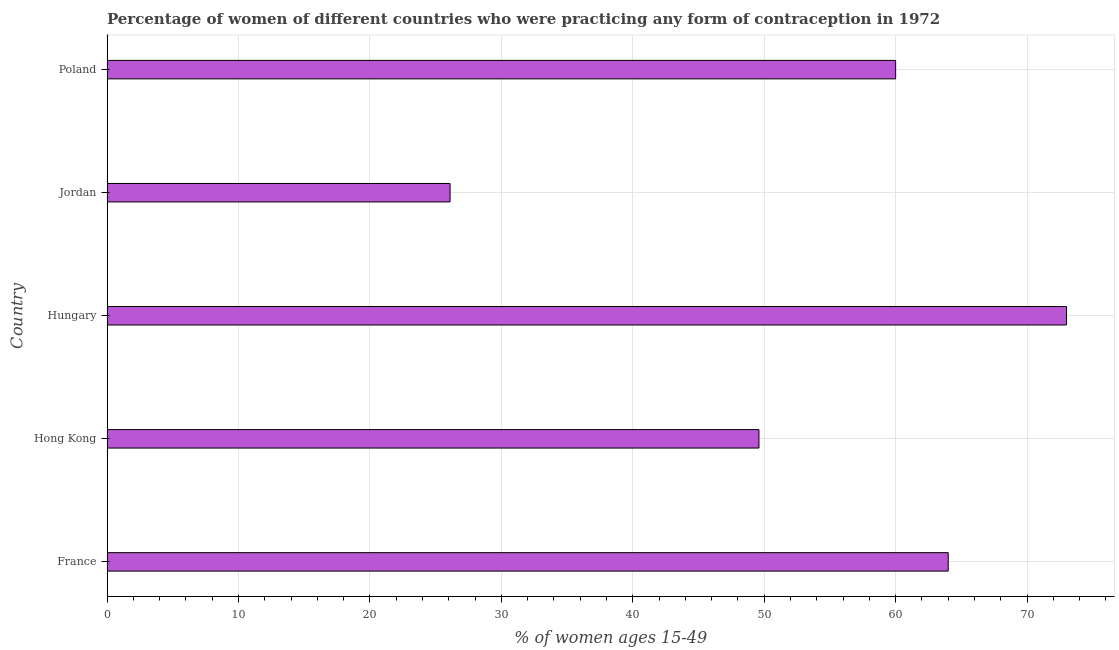Does the graph contain any zero values?
Provide a succinct answer. No. Does the graph contain grids?
Provide a succinct answer. Yes. What is the title of the graph?
Provide a succinct answer. Percentage of women of different countries who were practicing any form of contraception in 1972. What is the label or title of the X-axis?
Offer a terse response. % of women ages 15-49. Across all countries, what is the maximum contraceptive prevalence?
Keep it short and to the point. 73. Across all countries, what is the minimum contraceptive prevalence?
Your answer should be compact. 26.1. In which country was the contraceptive prevalence maximum?
Ensure brevity in your answer.  Hungary. In which country was the contraceptive prevalence minimum?
Ensure brevity in your answer.  Jordan. What is the sum of the contraceptive prevalence?
Provide a short and direct response. 272.7. What is the average contraceptive prevalence per country?
Your answer should be compact. 54.54. In how many countries, is the contraceptive prevalence greater than 8 %?
Give a very brief answer. 5. What is the ratio of the contraceptive prevalence in Hungary to that in Jordan?
Your response must be concise. 2.8. Is the contraceptive prevalence in Hong Kong less than that in Jordan?
Your response must be concise. No. Is the difference between the contraceptive prevalence in Hong Kong and Hungary greater than the difference between any two countries?
Provide a succinct answer. No. What is the difference between the highest and the second highest contraceptive prevalence?
Your answer should be compact. 9. What is the difference between the highest and the lowest contraceptive prevalence?
Provide a short and direct response. 46.9. In how many countries, is the contraceptive prevalence greater than the average contraceptive prevalence taken over all countries?
Keep it short and to the point. 3. What is the % of women ages 15-49 of Hong Kong?
Your answer should be compact. 49.6. What is the % of women ages 15-49 in Hungary?
Provide a succinct answer. 73. What is the % of women ages 15-49 in Jordan?
Offer a terse response. 26.1. What is the % of women ages 15-49 in Poland?
Provide a short and direct response. 60. What is the difference between the % of women ages 15-49 in France and Hong Kong?
Offer a terse response. 14.4. What is the difference between the % of women ages 15-49 in France and Jordan?
Your answer should be very brief. 37.9. What is the difference between the % of women ages 15-49 in France and Poland?
Offer a terse response. 4. What is the difference between the % of women ages 15-49 in Hong Kong and Hungary?
Give a very brief answer. -23.4. What is the difference between the % of women ages 15-49 in Hong Kong and Jordan?
Provide a short and direct response. 23.5. What is the difference between the % of women ages 15-49 in Hong Kong and Poland?
Offer a very short reply. -10.4. What is the difference between the % of women ages 15-49 in Hungary and Jordan?
Give a very brief answer. 46.9. What is the difference between the % of women ages 15-49 in Jordan and Poland?
Make the answer very short. -33.9. What is the ratio of the % of women ages 15-49 in France to that in Hong Kong?
Keep it short and to the point. 1.29. What is the ratio of the % of women ages 15-49 in France to that in Hungary?
Provide a succinct answer. 0.88. What is the ratio of the % of women ages 15-49 in France to that in Jordan?
Provide a succinct answer. 2.45. What is the ratio of the % of women ages 15-49 in France to that in Poland?
Make the answer very short. 1.07. What is the ratio of the % of women ages 15-49 in Hong Kong to that in Hungary?
Provide a short and direct response. 0.68. What is the ratio of the % of women ages 15-49 in Hong Kong to that in Jordan?
Offer a very short reply. 1.9. What is the ratio of the % of women ages 15-49 in Hong Kong to that in Poland?
Your response must be concise. 0.83. What is the ratio of the % of women ages 15-49 in Hungary to that in Jordan?
Your answer should be very brief. 2.8. What is the ratio of the % of women ages 15-49 in Hungary to that in Poland?
Keep it short and to the point. 1.22. What is the ratio of the % of women ages 15-49 in Jordan to that in Poland?
Your response must be concise. 0.43. 